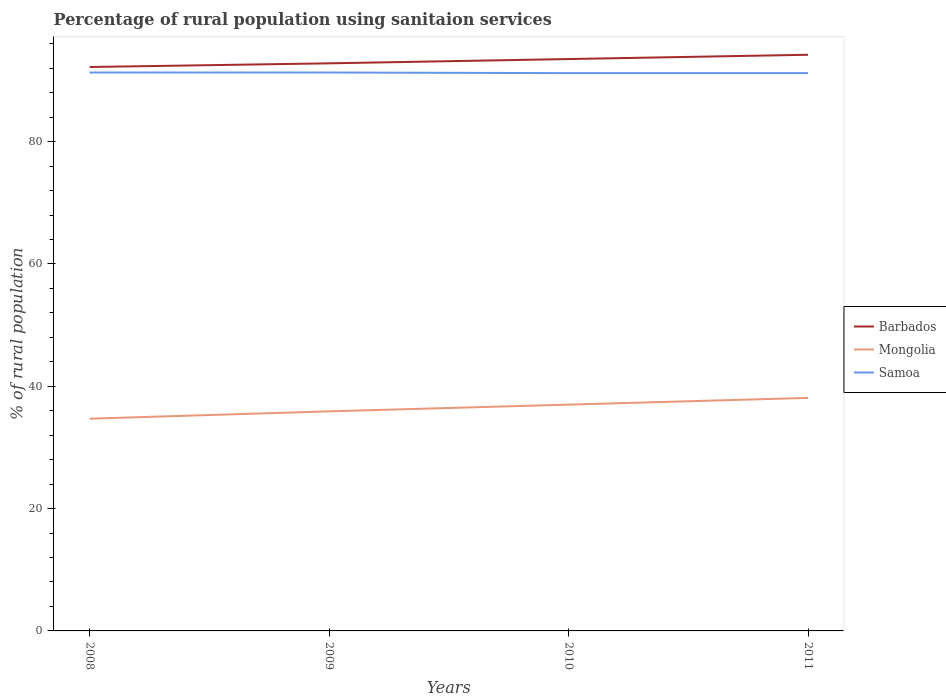How many different coloured lines are there?
Provide a succinct answer. 3. Does the line corresponding to Mongolia intersect with the line corresponding to Samoa?
Your answer should be compact. No. Across all years, what is the maximum percentage of rural population using sanitaion services in Barbados?
Give a very brief answer. 92.2. In which year was the percentage of rural population using sanitaion services in Samoa maximum?
Offer a very short reply. 2010. What is the total percentage of rural population using sanitaion services in Mongolia in the graph?
Keep it short and to the point. -2.3. What is the difference between the highest and the second highest percentage of rural population using sanitaion services in Barbados?
Offer a terse response. 2. What is the difference between the highest and the lowest percentage of rural population using sanitaion services in Samoa?
Give a very brief answer. 2. How many lines are there?
Your answer should be compact. 3. What is the difference between two consecutive major ticks on the Y-axis?
Offer a terse response. 20. Are the values on the major ticks of Y-axis written in scientific E-notation?
Offer a terse response. No. How many legend labels are there?
Your response must be concise. 3. How are the legend labels stacked?
Keep it short and to the point. Vertical. What is the title of the graph?
Your response must be concise. Percentage of rural population using sanitaion services. What is the label or title of the X-axis?
Offer a very short reply. Years. What is the label or title of the Y-axis?
Provide a succinct answer. % of rural population. What is the % of rural population of Barbados in 2008?
Your answer should be compact. 92.2. What is the % of rural population of Mongolia in 2008?
Offer a terse response. 34.7. What is the % of rural population in Samoa in 2008?
Offer a terse response. 91.3. What is the % of rural population in Barbados in 2009?
Make the answer very short. 92.8. What is the % of rural population in Mongolia in 2009?
Give a very brief answer. 35.9. What is the % of rural population of Samoa in 2009?
Offer a terse response. 91.3. What is the % of rural population of Barbados in 2010?
Offer a terse response. 93.5. What is the % of rural population in Samoa in 2010?
Keep it short and to the point. 91.2. What is the % of rural population of Barbados in 2011?
Give a very brief answer. 94.2. What is the % of rural population of Mongolia in 2011?
Make the answer very short. 38.1. What is the % of rural population of Samoa in 2011?
Provide a succinct answer. 91.2. Across all years, what is the maximum % of rural population in Barbados?
Your answer should be compact. 94.2. Across all years, what is the maximum % of rural population of Mongolia?
Your answer should be compact. 38.1. Across all years, what is the maximum % of rural population of Samoa?
Make the answer very short. 91.3. Across all years, what is the minimum % of rural population in Barbados?
Give a very brief answer. 92.2. Across all years, what is the minimum % of rural population of Mongolia?
Offer a terse response. 34.7. Across all years, what is the minimum % of rural population of Samoa?
Provide a short and direct response. 91.2. What is the total % of rural population in Barbados in the graph?
Provide a succinct answer. 372.7. What is the total % of rural population of Mongolia in the graph?
Ensure brevity in your answer.  145.7. What is the total % of rural population of Samoa in the graph?
Your answer should be very brief. 365. What is the difference between the % of rural population in Barbados in 2008 and that in 2009?
Your answer should be compact. -0.6. What is the difference between the % of rural population in Mongolia in 2008 and that in 2009?
Give a very brief answer. -1.2. What is the difference between the % of rural population in Samoa in 2008 and that in 2011?
Provide a succinct answer. 0.1. What is the difference between the % of rural population in Mongolia in 2009 and that in 2010?
Offer a very short reply. -1.1. What is the difference between the % of rural population in Barbados in 2009 and that in 2011?
Provide a short and direct response. -1.4. What is the difference between the % of rural population of Mongolia in 2009 and that in 2011?
Make the answer very short. -2.2. What is the difference between the % of rural population in Samoa in 2009 and that in 2011?
Make the answer very short. 0.1. What is the difference between the % of rural population of Barbados in 2010 and that in 2011?
Your answer should be very brief. -0.7. What is the difference between the % of rural population in Barbados in 2008 and the % of rural population in Mongolia in 2009?
Give a very brief answer. 56.3. What is the difference between the % of rural population in Mongolia in 2008 and the % of rural population in Samoa in 2009?
Offer a terse response. -56.6. What is the difference between the % of rural population of Barbados in 2008 and the % of rural population of Mongolia in 2010?
Ensure brevity in your answer.  55.2. What is the difference between the % of rural population of Mongolia in 2008 and the % of rural population of Samoa in 2010?
Provide a short and direct response. -56.5. What is the difference between the % of rural population of Barbados in 2008 and the % of rural population of Mongolia in 2011?
Provide a succinct answer. 54.1. What is the difference between the % of rural population in Barbados in 2008 and the % of rural population in Samoa in 2011?
Provide a succinct answer. 1. What is the difference between the % of rural population in Mongolia in 2008 and the % of rural population in Samoa in 2011?
Provide a succinct answer. -56.5. What is the difference between the % of rural population in Barbados in 2009 and the % of rural population in Mongolia in 2010?
Your answer should be very brief. 55.8. What is the difference between the % of rural population of Barbados in 2009 and the % of rural population of Samoa in 2010?
Keep it short and to the point. 1.6. What is the difference between the % of rural population of Mongolia in 2009 and the % of rural population of Samoa in 2010?
Keep it short and to the point. -55.3. What is the difference between the % of rural population in Barbados in 2009 and the % of rural population in Mongolia in 2011?
Ensure brevity in your answer.  54.7. What is the difference between the % of rural population in Barbados in 2009 and the % of rural population in Samoa in 2011?
Provide a short and direct response. 1.6. What is the difference between the % of rural population in Mongolia in 2009 and the % of rural population in Samoa in 2011?
Keep it short and to the point. -55.3. What is the difference between the % of rural population in Barbados in 2010 and the % of rural population in Mongolia in 2011?
Offer a terse response. 55.4. What is the difference between the % of rural population of Barbados in 2010 and the % of rural population of Samoa in 2011?
Offer a very short reply. 2.3. What is the difference between the % of rural population of Mongolia in 2010 and the % of rural population of Samoa in 2011?
Keep it short and to the point. -54.2. What is the average % of rural population of Barbados per year?
Offer a very short reply. 93.17. What is the average % of rural population in Mongolia per year?
Keep it short and to the point. 36.42. What is the average % of rural population in Samoa per year?
Your answer should be compact. 91.25. In the year 2008, what is the difference between the % of rural population in Barbados and % of rural population in Mongolia?
Your answer should be very brief. 57.5. In the year 2008, what is the difference between the % of rural population of Barbados and % of rural population of Samoa?
Give a very brief answer. 0.9. In the year 2008, what is the difference between the % of rural population in Mongolia and % of rural population in Samoa?
Offer a terse response. -56.6. In the year 2009, what is the difference between the % of rural population in Barbados and % of rural population in Mongolia?
Keep it short and to the point. 56.9. In the year 2009, what is the difference between the % of rural population in Mongolia and % of rural population in Samoa?
Provide a short and direct response. -55.4. In the year 2010, what is the difference between the % of rural population of Barbados and % of rural population of Mongolia?
Your answer should be compact. 56.5. In the year 2010, what is the difference between the % of rural population in Barbados and % of rural population in Samoa?
Your answer should be compact. 2.3. In the year 2010, what is the difference between the % of rural population of Mongolia and % of rural population of Samoa?
Ensure brevity in your answer.  -54.2. In the year 2011, what is the difference between the % of rural population in Barbados and % of rural population in Mongolia?
Give a very brief answer. 56.1. In the year 2011, what is the difference between the % of rural population in Barbados and % of rural population in Samoa?
Give a very brief answer. 3. In the year 2011, what is the difference between the % of rural population of Mongolia and % of rural population of Samoa?
Offer a very short reply. -53.1. What is the ratio of the % of rural population in Barbados in 2008 to that in 2009?
Offer a very short reply. 0.99. What is the ratio of the % of rural population of Mongolia in 2008 to that in 2009?
Offer a terse response. 0.97. What is the ratio of the % of rural population in Barbados in 2008 to that in 2010?
Offer a very short reply. 0.99. What is the ratio of the % of rural population in Mongolia in 2008 to that in 2010?
Give a very brief answer. 0.94. What is the ratio of the % of rural population of Samoa in 2008 to that in 2010?
Ensure brevity in your answer.  1. What is the ratio of the % of rural population of Barbados in 2008 to that in 2011?
Keep it short and to the point. 0.98. What is the ratio of the % of rural population in Mongolia in 2008 to that in 2011?
Give a very brief answer. 0.91. What is the ratio of the % of rural population of Barbados in 2009 to that in 2010?
Your response must be concise. 0.99. What is the ratio of the % of rural population in Mongolia in 2009 to that in 2010?
Offer a terse response. 0.97. What is the ratio of the % of rural population in Samoa in 2009 to that in 2010?
Your response must be concise. 1. What is the ratio of the % of rural population in Barbados in 2009 to that in 2011?
Provide a succinct answer. 0.99. What is the ratio of the % of rural population of Mongolia in 2009 to that in 2011?
Offer a very short reply. 0.94. What is the ratio of the % of rural population of Samoa in 2009 to that in 2011?
Your answer should be very brief. 1. What is the ratio of the % of rural population in Barbados in 2010 to that in 2011?
Give a very brief answer. 0.99. What is the ratio of the % of rural population of Mongolia in 2010 to that in 2011?
Offer a terse response. 0.97. What is the difference between the highest and the second highest % of rural population in Samoa?
Keep it short and to the point. 0. What is the difference between the highest and the lowest % of rural population in Barbados?
Give a very brief answer. 2. What is the difference between the highest and the lowest % of rural population of Mongolia?
Keep it short and to the point. 3.4. What is the difference between the highest and the lowest % of rural population of Samoa?
Your answer should be very brief. 0.1. 